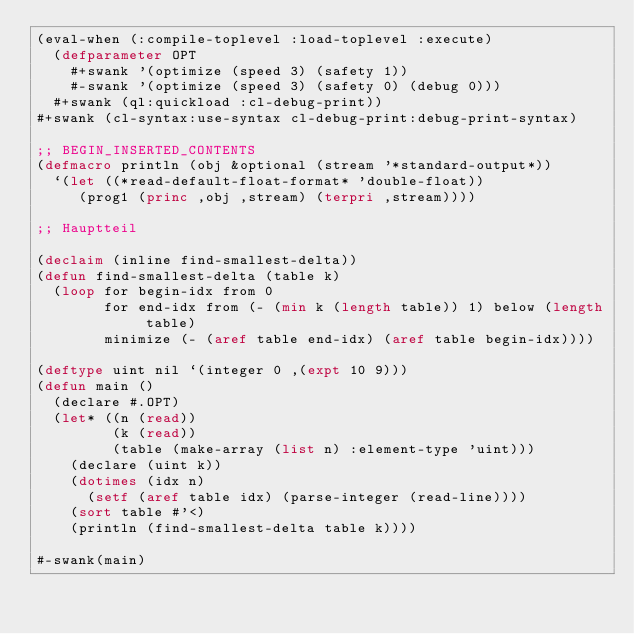<code> <loc_0><loc_0><loc_500><loc_500><_Lisp_>(eval-when (:compile-toplevel :load-toplevel :execute)
  (defparameter OPT
    #+swank '(optimize (speed 3) (safety 1))
    #-swank '(optimize (speed 3) (safety 0) (debug 0)))
  #+swank (ql:quickload :cl-debug-print))
#+swank (cl-syntax:use-syntax cl-debug-print:debug-print-syntax)

;; BEGIN_INSERTED_CONTENTS
(defmacro println (obj &optional (stream '*standard-output*))
  `(let ((*read-default-float-format* 'double-float))
     (prog1 (princ ,obj ,stream) (terpri ,stream))))

;; Hauptteil

(declaim (inline find-smallest-delta))
(defun find-smallest-delta (table k)
  (loop for begin-idx from 0
        for end-idx from (- (min k (length table)) 1) below (length table)
        minimize (- (aref table end-idx) (aref table begin-idx))))

(deftype uint nil `(integer 0 ,(expt 10 9)))
(defun main ()
  (declare #.OPT)
  (let* ((n (read))
         (k (read))
         (table (make-array (list n) :element-type 'uint)))
    (declare (uint k))
    (dotimes (idx n)
      (setf (aref table idx) (parse-integer (read-line))))
    (sort table #'<)
    (println (find-smallest-delta table k))))

#-swank(main)
</code> 